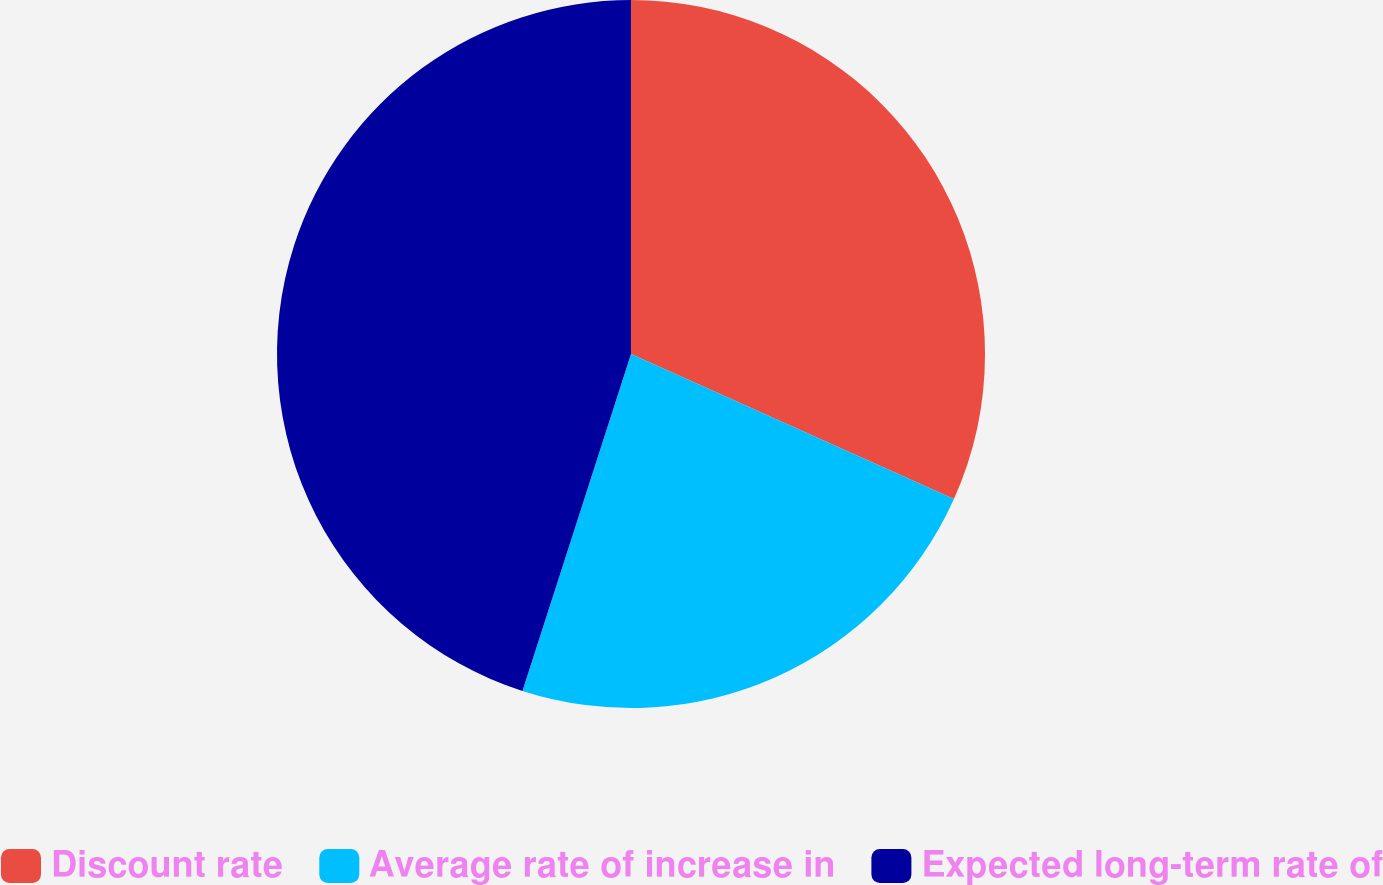Convert chart to OTSL. <chart><loc_0><loc_0><loc_500><loc_500><pie_chart><fcel>Discount rate<fcel>Average rate of increase in<fcel>Expected long-term rate of<nl><fcel>31.72%<fcel>23.24%<fcel>45.04%<nl></chart> 